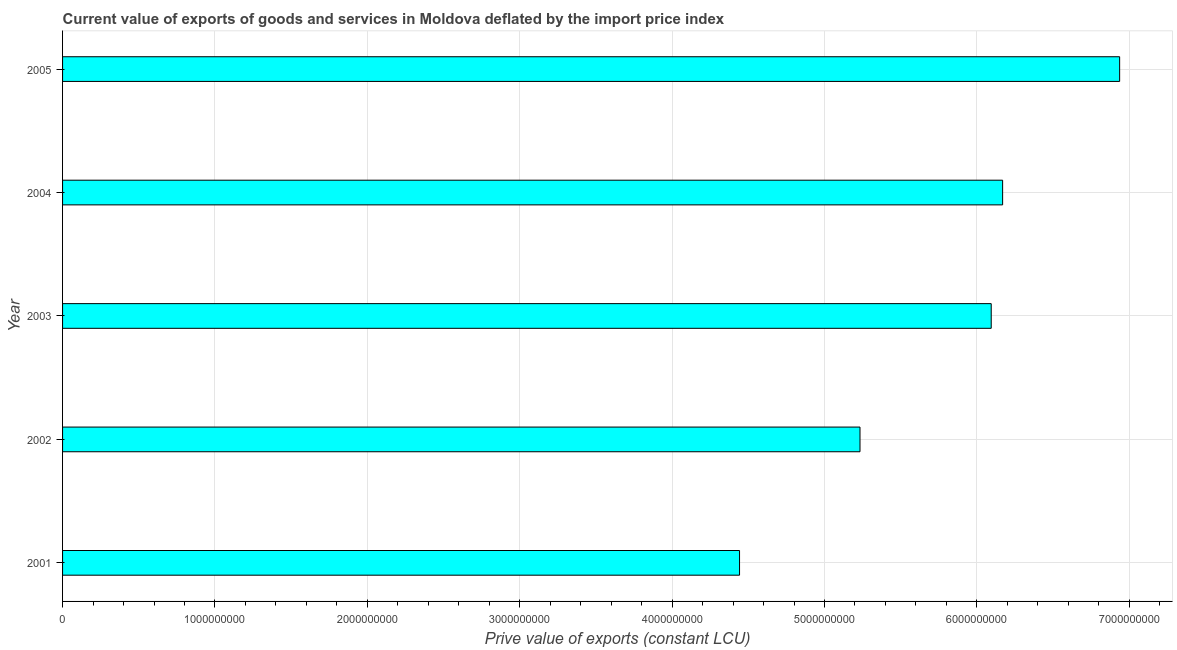Does the graph contain grids?
Offer a terse response. Yes. What is the title of the graph?
Provide a succinct answer. Current value of exports of goods and services in Moldova deflated by the import price index. What is the label or title of the X-axis?
Your answer should be compact. Prive value of exports (constant LCU). What is the price value of exports in 2005?
Offer a very short reply. 6.94e+09. Across all years, what is the maximum price value of exports?
Offer a very short reply. 6.94e+09. Across all years, what is the minimum price value of exports?
Give a very brief answer. 4.44e+09. What is the sum of the price value of exports?
Provide a short and direct response. 2.89e+1. What is the difference between the price value of exports in 2002 and 2004?
Offer a very short reply. -9.36e+08. What is the average price value of exports per year?
Give a very brief answer. 5.78e+09. What is the median price value of exports?
Provide a succinct answer. 6.09e+09. In how many years, is the price value of exports greater than 2800000000 LCU?
Make the answer very short. 5. Do a majority of the years between 2001 and 2004 (inclusive) have price value of exports greater than 1600000000 LCU?
Offer a very short reply. Yes. What is the ratio of the price value of exports in 2003 to that in 2004?
Your response must be concise. 0.99. Is the price value of exports in 2004 less than that in 2005?
Give a very brief answer. Yes. Is the difference between the price value of exports in 2001 and 2003 greater than the difference between any two years?
Keep it short and to the point. No. What is the difference between the highest and the second highest price value of exports?
Provide a short and direct response. 7.68e+08. What is the difference between the highest and the lowest price value of exports?
Keep it short and to the point. 2.49e+09. How many bars are there?
Your answer should be very brief. 5. How many years are there in the graph?
Offer a very short reply. 5. Are the values on the major ticks of X-axis written in scientific E-notation?
Provide a short and direct response. No. What is the Prive value of exports (constant LCU) of 2001?
Provide a short and direct response. 4.44e+09. What is the Prive value of exports (constant LCU) of 2002?
Your response must be concise. 5.23e+09. What is the Prive value of exports (constant LCU) of 2003?
Provide a succinct answer. 6.09e+09. What is the Prive value of exports (constant LCU) in 2004?
Make the answer very short. 6.17e+09. What is the Prive value of exports (constant LCU) in 2005?
Give a very brief answer. 6.94e+09. What is the difference between the Prive value of exports (constant LCU) in 2001 and 2002?
Make the answer very short. -7.90e+08. What is the difference between the Prive value of exports (constant LCU) in 2001 and 2003?
Make the answer very short. -1.65e+09. What is the difference between the Prive value of exports (constant LCU) in 2001 and 2004?
Offer a very short reply. -1.73e+09. What is the difference between the Prive value of exports (constant LCU) in 2001 and 2005?
Ensure brevity in your answer.  -2.49e+09. What is the difference between the Prive value of exports (constant LCU) in 2002 and 2003?
Ensure brevity in your answer.  -8.61e+08. What is the difference between the Prive value of exports (constant LCU) in 2002 and 2004?
Give a very brief answer. -9.36e+08. What is the difference between the Prive value of exports (constant LCU) in 2002 and 2005?
Keep it short and to the point. -1.70e+09. What is the difference between the Prive value of exports (constant LCU) in 2003 and 2004?
Your response must be concise. -7.48e+07. What is the difference between the Prive value of exports (constant LCU) in 2003 and 2005?
Ensure brevity in your answer.  -8.43e+08. What is the difference between the Prive value of exports (constant LCU) in 2004 and 2005?
Give a very brief answer. -7.68e+08. What is the ratio of the Prive value of exports (constant LCU) in 2001 to that in 2002?
Ensure brevity in your answer.  0.85. What is the ratio of the Prive value of exports (constant LCU) in 2001 to that in 2003?
Provide a succinct answer. 0.73. What is the ratio of the Prive value of exports (constant LCU) in 2001 to that in 2004?
Provide a short and direct response. 0.72. What is the ratio of the Prive value of exports (constant LCU) in 2001 to that in 2005?
Your response must be concise. 0.64. What is the ratio of the Prive value of exports (constant LCU) in 2002 to that in 2003?
Offer a very short reply. 0.86. What is the ratio of the Prive value of exports (constant LCU) in 2002 to that in 2004?
Ensure brevity in your answer.  0.85. What is the ratio of the Prive value of exports (constant LCU) in 2002 to that in 2005?
Offer a very short reply. 0.75. What is the ratio of the Prive value of exports (constant LCU) in 2003 to that in 2005?
Offer a very short reply. 0.88. What is the ratio of the Prive value of exports (constant LCU) in 2004 to that in 2005?
Make the answer very short. 0.89. 